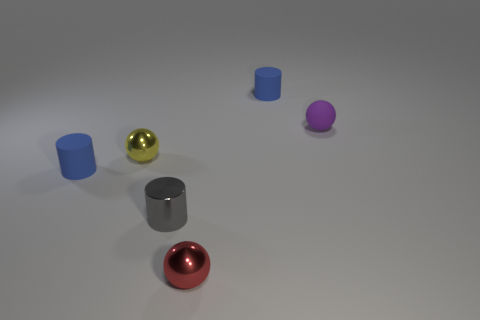What emotions or ideas might this arrangement of objects evoke in a viewer? The arrangement has a minimalist yet playful quality that could evoke a sense of curiosity and simplicity. The clean lines and basic forms may resonate with those who appreciate modern art and design. 